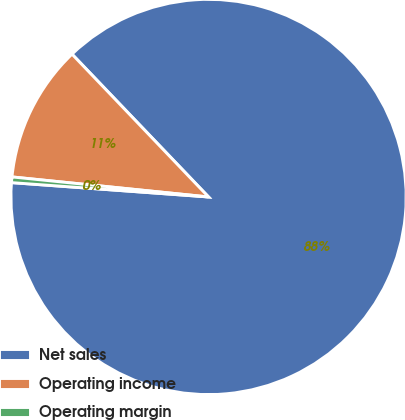<chart> <loc_0><loc_0><loc_500><loc_500><pie_chart><fcel>Net sales<fcel>Operating income<fcel>Operating margin<nl><fcel>88.3%<fcel>11.24%<fcel>0.46%<nl></chart> 